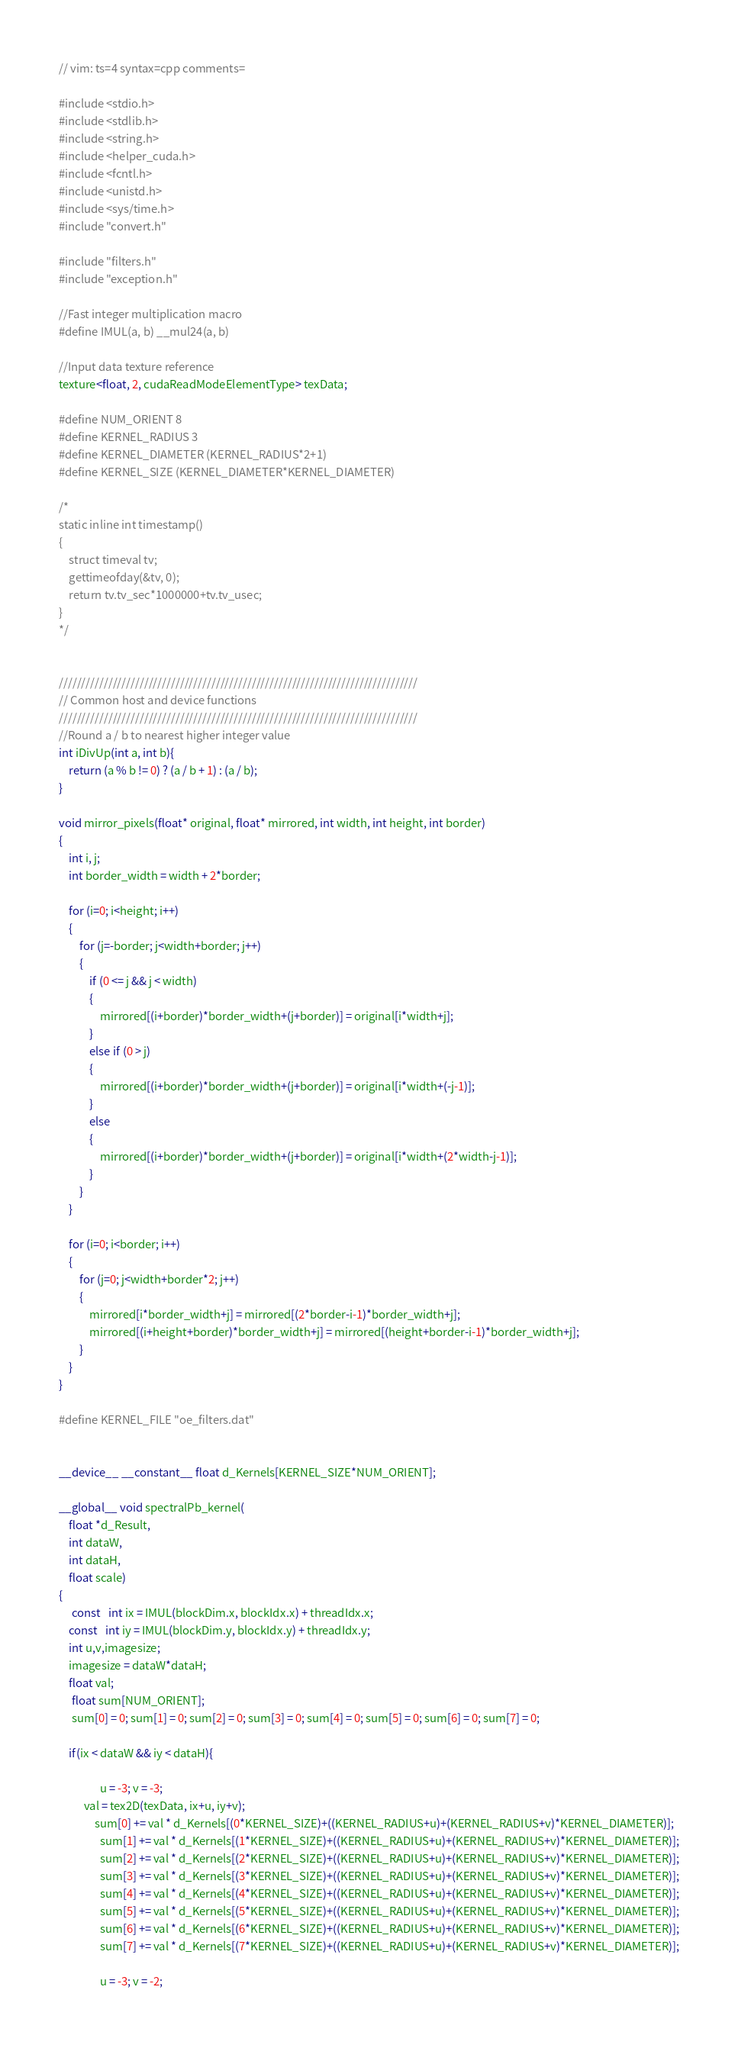<code> <loc_0><loc_0><loc_500><loc_500><_Cuda_>// vim: ts=4 syntax=cpp comments=

#include <stdio.h>
#include <stdlib.h>
#include <string.h>
#include <helper_cuda.h>
#include <fcntl.h>
#include <unistd.h>
#include <sys/time.h>
#include "convert.h"

#include "filters.h"
#include "exception.h"

//Fast integer multiplication macro
#define IMUL(a, b) __mul24(a, b)

//Input data texture reference
texture<float, 2, cudaReadModeElementType> texData;

#define NUM_ORIENT 8
#define KERNEL_RADIUS 3
#define KERNEL_DIAMETER (KERNEL_RADIUS*2+1)
#define KERNEL_SIZE (KERNEL_DIAMETER*KERNEL_DIAMETER)

/*
static inline int timestamp()
{
    struct timeval tv;
    gettimeofday(&tv, 0);
    return tv.tv_sec*1000000+tv.tv_usec;
}
*/


////////////////////////////////////////////////////////////////////////////////
// Common host and device functions
////////////////////////////////////////////////////////////////////////////////
//Round a / b to nearest higher integer value
int iDivUp(int a, int b){
    return (a % b != 0) ? (a / b + 1) : (a / b);
}

void mirror_pixels(float* original, float* mirrored, int width, int height, int border)
{
    int i, j;
    int border_width = width + 2*border;

    for (i=0; i<height; i++)
    {
        for (j=-border; j<width+border; j++)
        {
            if (0 <= j && j < width)
            {
                mirrored[(i+border)*border_width+(j+border)] = original[i*width+j];
            }
            else if (0 > j)
            {
                mirrored[(i+border)*border_width+(j+border)] = original[i*width+(-j-1)];
            }
            else
            {
                mirrored[(i+border)*border_width+(j+border)] = original[i*width+(2*width-j-1)];
            }
        }
    }

    for (i=0; i<border; i++)
    {
        for (j=0; j<width+border*2; j++)
        {
            mirrored[i*border_width+j] = mirrored[(2*border-i-1)*border_width+j];
            mirrored[(i+height+border)*border_width+j] = mirrored[(height+border-i-1)*border_width+j];
        }
    }
}

#define KERNEL_FILE "oe_filters.dat"


__device__ __constant__ float d_Kernels[KERNEL_SIZE*NUM_ORIENT];

__global__ void spectralPb_kernel(
	float *d_Result,
	int dataW,
	int dataH,
	float scale)
{
	 const   int ix = IMUL(blockDim.x, blockIdx.x) + threadIdx.x;
    const   int iy = IMUL(blockDim.y, blockIdx.y) + threadIdx.y;
    int u,v,imagesize;
    imagesize = dataW*dataH;
    float val;
	 float sum[NUM_ORIENT];
	 sum[0] = 0; sum[1] = 0; sum[2] = 0; sum[3] = 0; sum[4] = 0; sum[5] = 0; sum[6] = 0; sum[7] = 0;

    if(ix < dataW && iy < dataH){
    			
    			u = -3; v = -3;
          val = tex2D(texData, ix+u, iy+v);
     		  sum[0] += val * d_Kernels[(0*KERNEL_SIZE)+((KERNEL_RADIUS+u)+(KERNEL_RADIUS+v)*KERNEL_DIAMETER)];
				sum[1] += val * d_Kernels[(1*KERNEL_SIZE)+((KERNEL_RADIUS+u)+(KERNEL_RADIUS+v)*KERNEL_DIAMETER)];
				sum[2] += val * d_Kernels[(2*KERNEL_SIZE)+((KERNEL_RADIUS+u)+(KERNEL_RADIUS+v)*KERNEL_DIAMETER)];
				sum[3] += val * d_Kernels[(3*KERNEL_SIZE)+((KERNEL_RADIUS+u)+(KERNEL_RADIUS+v)*KERNEL_DIAMETER)];
				sum[4] += val * d_Kernels[(4*KERNEL_SIZE)+((KERNEL_RADIUS+u)+(KERNEL_RADIUS+v)*KERNEL_DIAMETER)];
				sum[5] += val * d_Kernels[(5*KERNEL_SIZE)+((KERNEL_RADIUS+u)+(KERNEL_RADIUS+v)*KERNEL_DIAMETER)];
				sum[6] += val * d_Kernels[(6*KERNEL_SIZE)+((KERNEL_RADIUS+u)+(KERNEL_RADIUS+v)*KERNEL_DIAMETER)];
				sum[7] += val * d_Kernels[(7*KERNEL_SIZE)+((KERNEL_RADIUS+u)+(KERNEL_RADIUS+v)*KERNEL_DIAMETER)];
				
    			u = -3; v = -2;</code> 